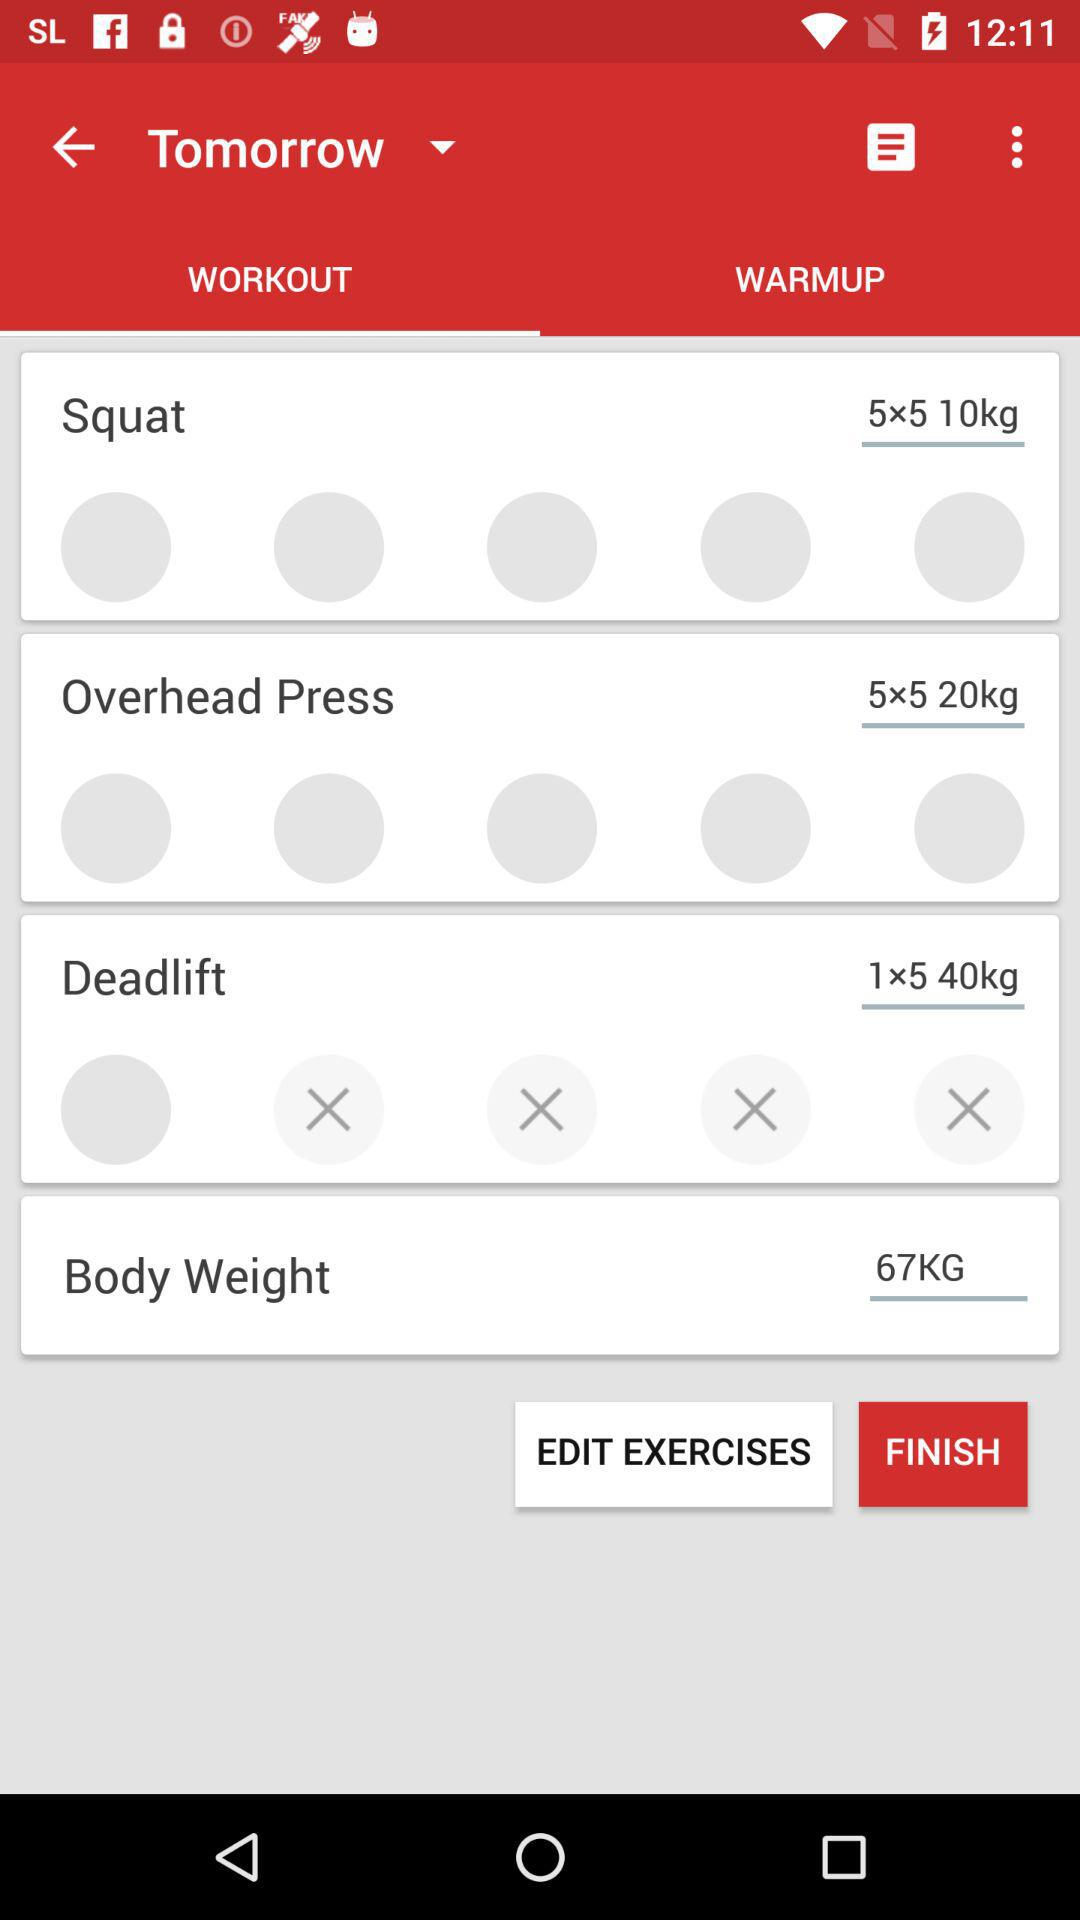What is the weight of the exercise 'Body Weight'?
Answer the question using a single word or phrase. 67KG 